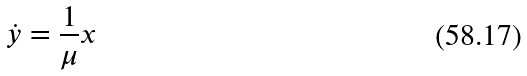<formula> <loc_0><loc_0><loc_500><loc_500>\dot { y } = \frac { 1 } { \mu } x</formula> 